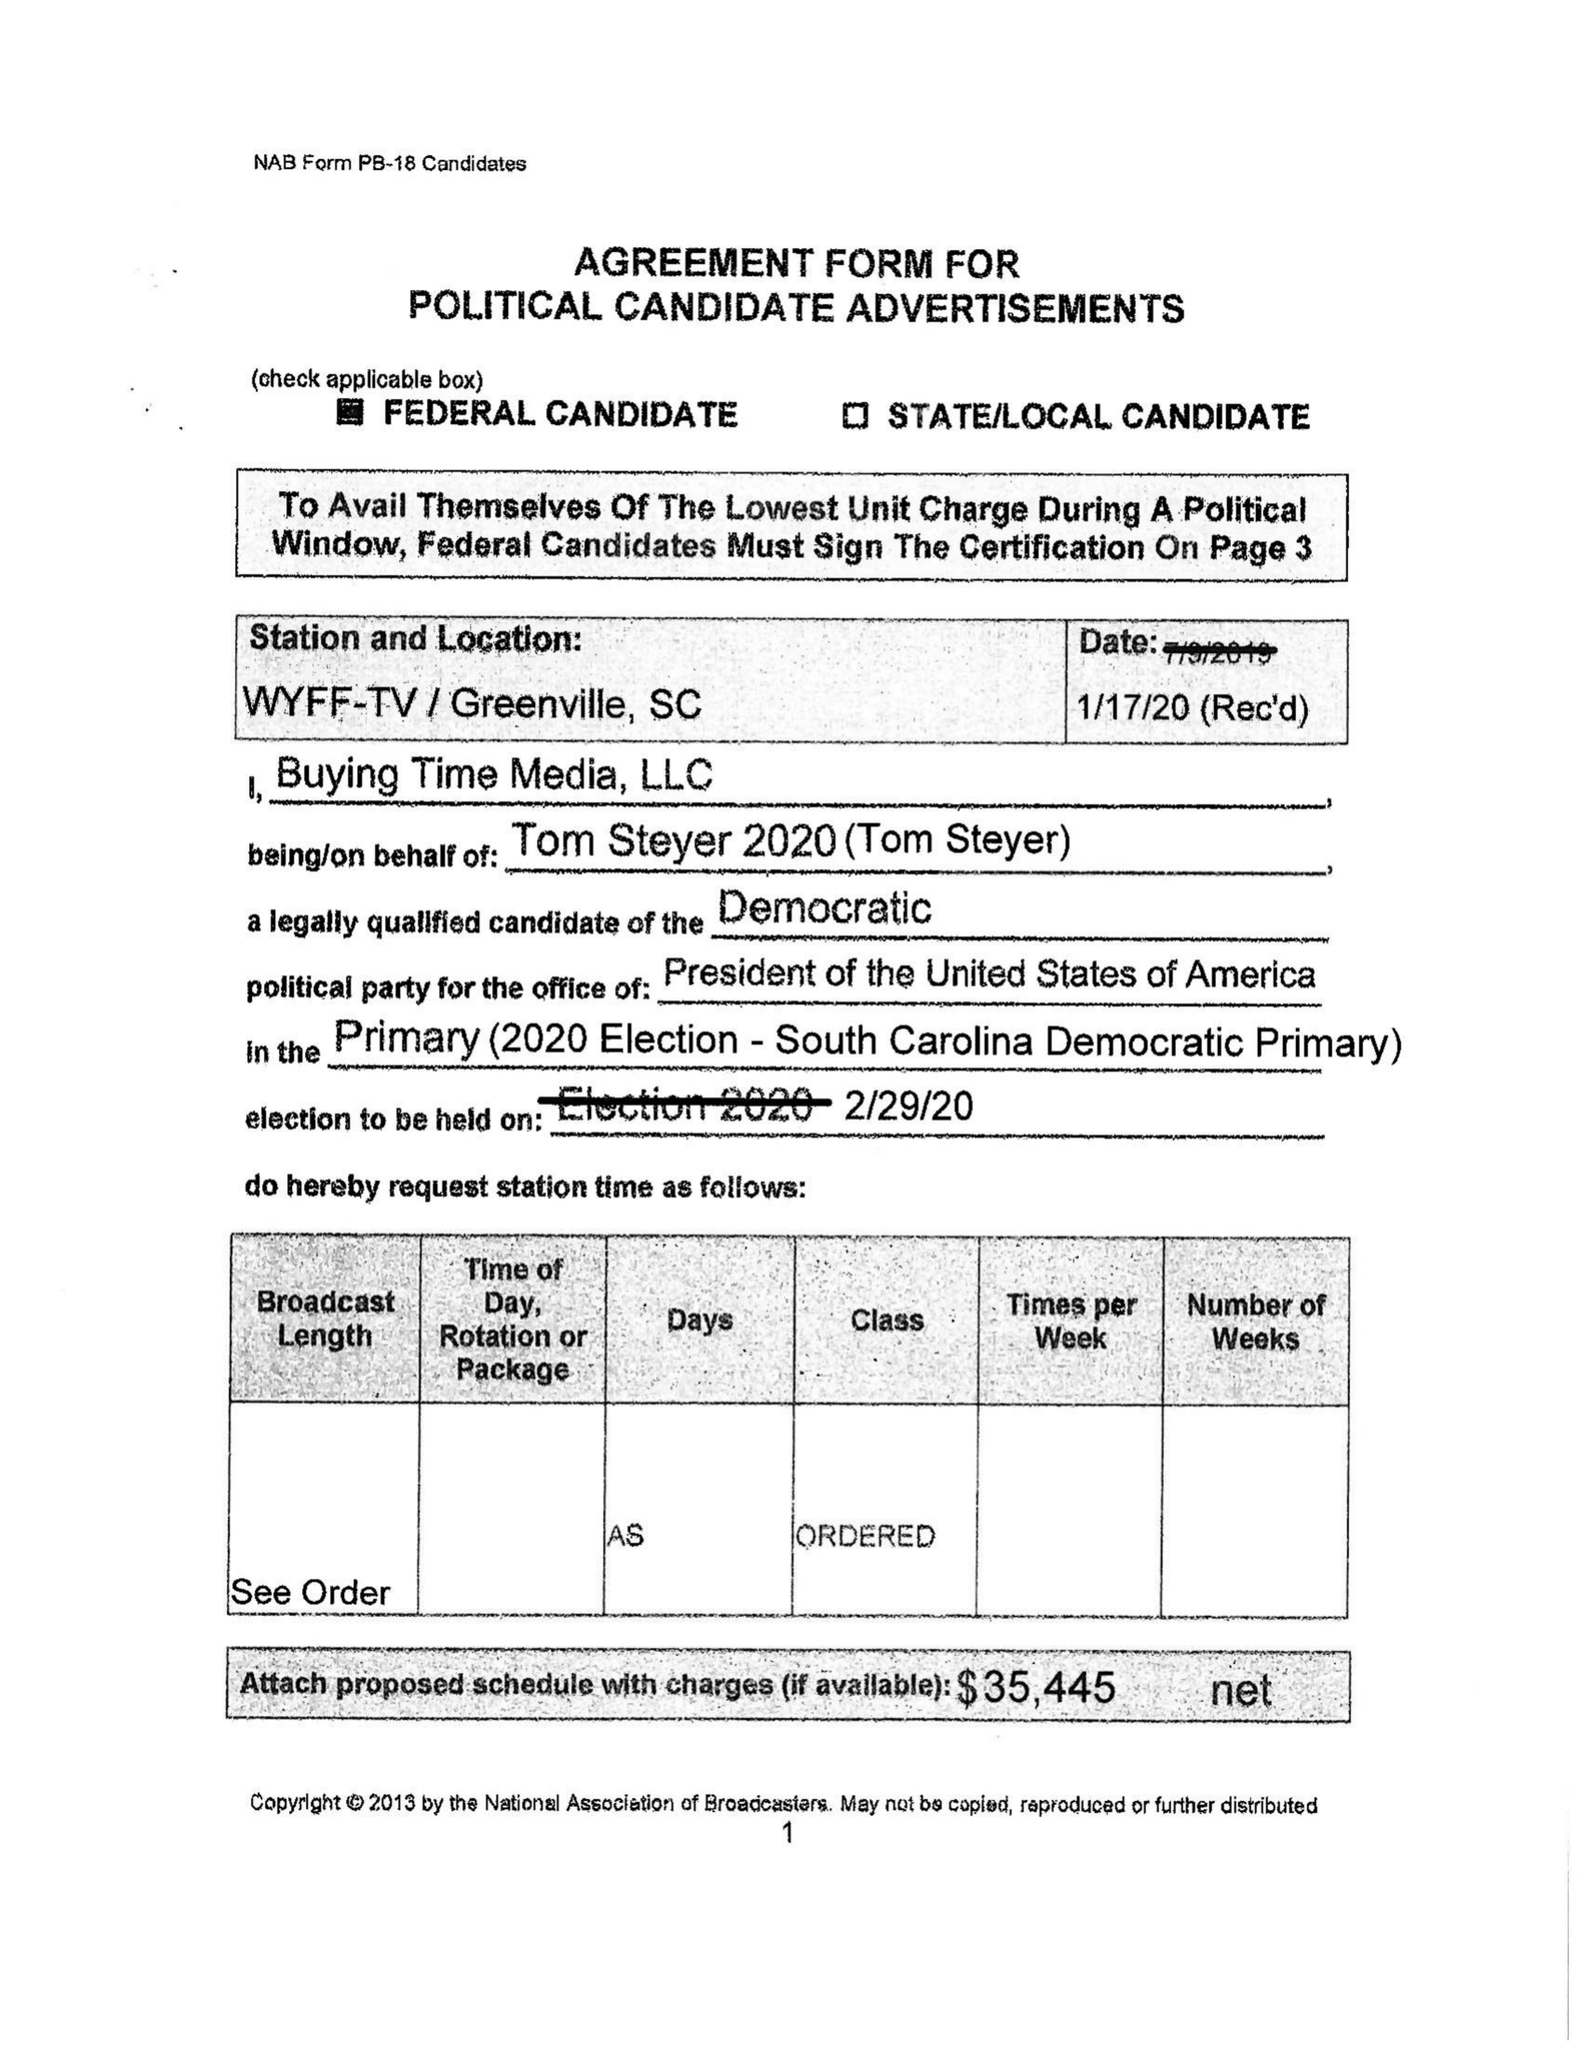What is the value for the flight_to?
Answer the question using a single word or phrase. None 